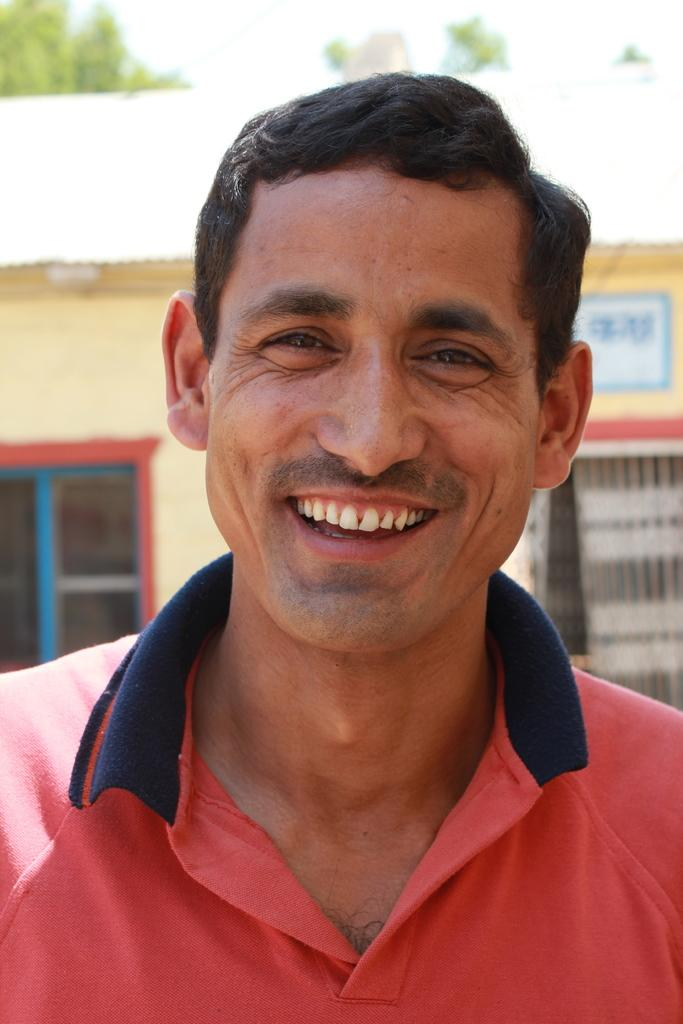Who is present in the image? There is a man in the image. What expression does the man have? The man is smiling. What can be seen in the background of the image? There is a building and trees in the background of the image. What type of kitty is guiding the man through the building in the image? There is no kitty present in the image, nor is there any indication that the man is being guided through a building. 